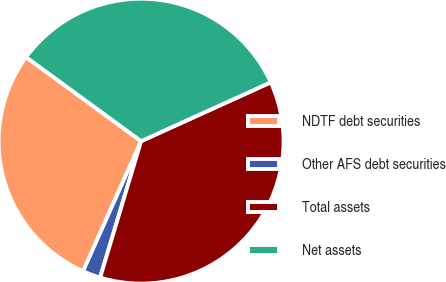<chart> <loc_0><loc_0><loc_500><loc_500><pie_chart><fcel>NDTF debt securities<fcel>Other AFS debt securities<fcel>Total assets<fcel>Net assets<nl><fcel>28.36%<fcel>2.04%<fcel>36.42%<fcel>33.18%<nl></chart> 